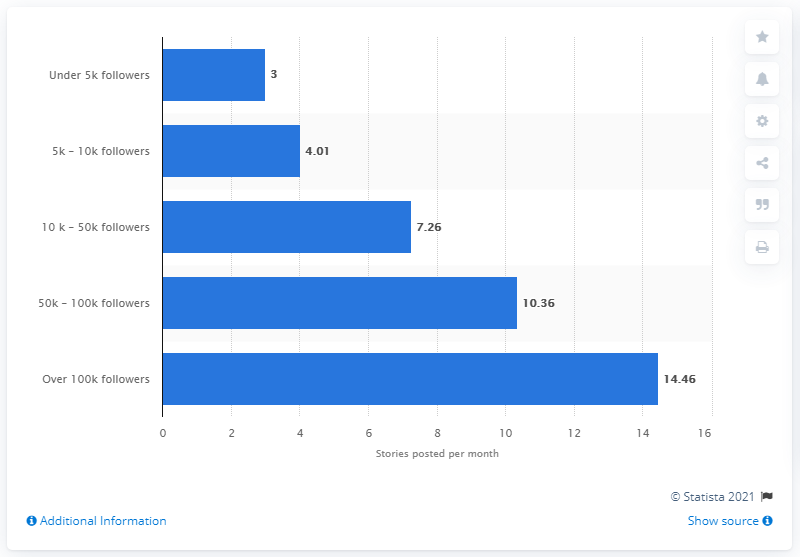Outline some significant characteristics in this image. On average, brands with over 100 thousand followers posted 14.46 stories per month. 